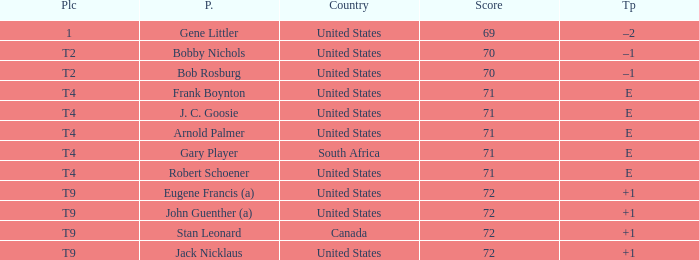What is To Par, when Country is "United States", when Place is "T4", and when Player is "Arnold Palmer"? E. Can you give me this table as a dict? {'header': ['Plc', 'P.', 'Country', 'Score', 'Tp'], 'rows': [['1', 'Gene Littler', 'United States', '69', '–2'], ['T2', 'Bobby Nichols', 'United States', '70', '–1'], ['T2', 'Bob Rosburg', 'United States', '70', '–1'], ['T4', 'Frank Boynton', 'United States', '71', 'E'], ['T4', 'J. C. Goosie', 'United States', '71', 'E'], ['T4', 'Arnold Palmer', 'United States', '71', 'E'], ['T4', 'Gary Player', 'South Africa', '71', 'E'], ['T4', 'Robert Schoener', 'United States', '71', 'E'], ['T9', 'Eugene Francis (a)', 'United States', '72', '+1'], ['T9', 'John Guenther (a)', 'United States', '72', '+1'], ['T9', 'Stan Leonard', 'Canada', '72', '+1'], ['T9', 'Jack Nicklaus', 'United States', '72', '+1']]} 